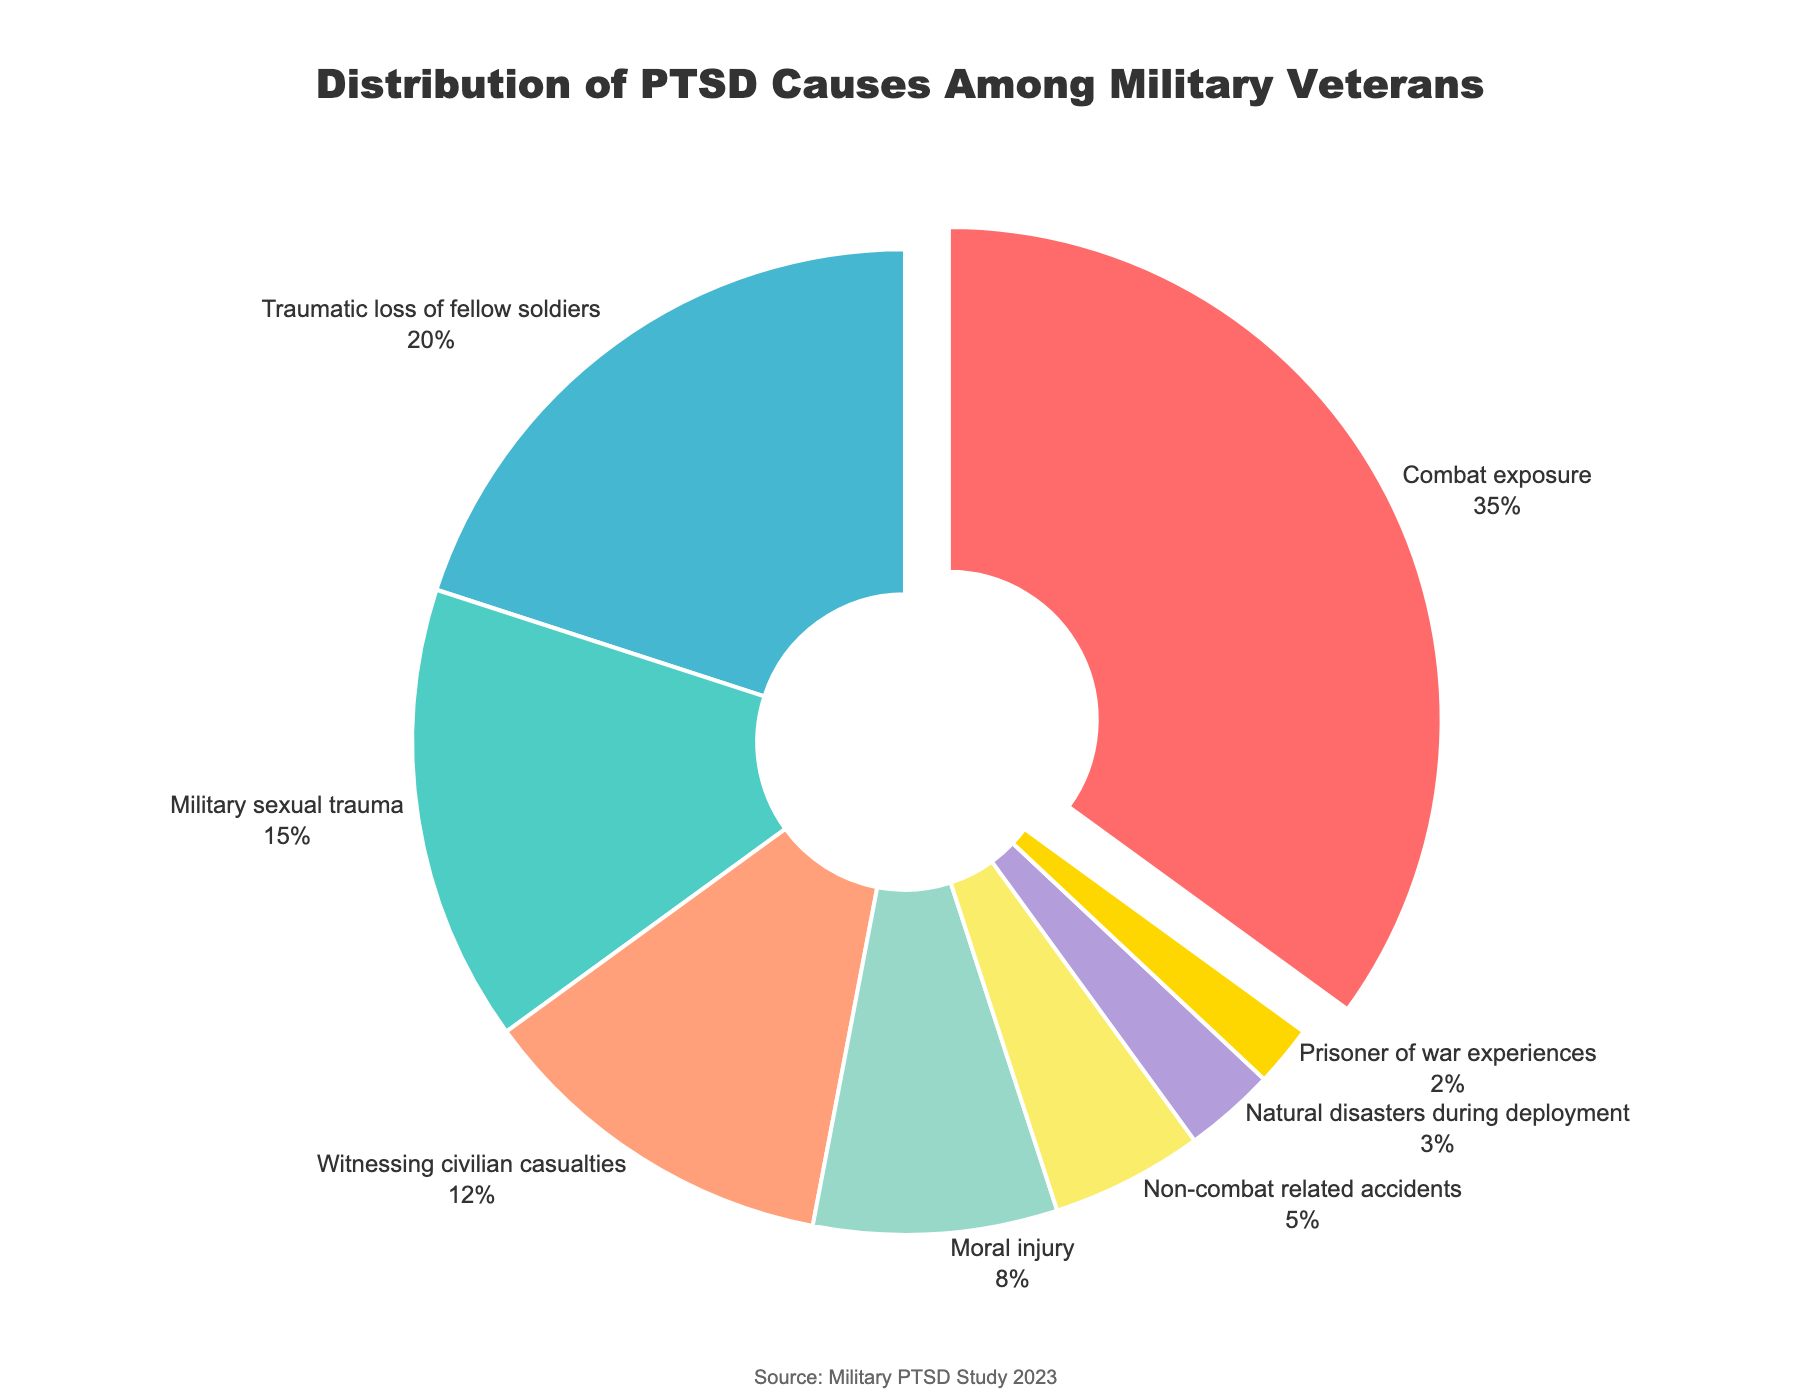What is the largest cause of PTSD among military veterans? The figure shows that "Combat exposure" is the largest slice of the pie, indicating it has the highest percentage.
Answer: Combat exposure What is the combined percentage of "Military sexual trauma" and "Traumatic loss of fellow soldiers"? "Military sexual trauma" is 15% and "Traumatic loss of fellow soldiers" is 20%. Adding these gives 15 + 20 = 35%.
Answer: 35% Which cause has a higher percentage: "Witnessing civilian casualties" or "Moral injury"? "Witnessing civilian casualties" is 12% and "Moral injury" is 8%. 12% is greater than 8%.
Answer: Witnessing civilian casualties What percentage of PTSD cases are caused by "Non-combat related accidents" and "Natural disasters during deployment" combined? "Non-combat related accidents" is 5% and "Natural disasters during deployment" is 3%. Adding these gives 5 + 3 = 8%.
Answer: 8% Which cause has the smallest percentage of PTSD among military veterans? The smallest slice of the pie is "Prisoner of war experiences" which is 2%.
Answer: Prisoner of war experiences How much more prevalent is "Traumatic loss of fellow soldiers" compared to "Non-combat related accidents"? "Traumatic loss of fellow soldiers" is 20% and "Non-combat related accidents" is 5%. The difference is 20 - 5 = 15%.
Answer: 15% What is the percentage of PTSD causes attributed to "Military sexual trauma" relative to "Combat exposure"? "Combat exposure" is 35% and "Military sexual trauma" is 15%. The relative percentage is (15 / 35) * 100 ≈ 42.86%.
Answer: ~42.86% Which causes have percentages above 10%? The pie chart shows that "Combat exposure" (35%), "Traumatic loss of fellow soldiers" (20%), and "Witnessing civilian casualties" (12%) all have percentages above 10%.
Answer: Combat exposure, Traumatic loss of fellow soldiers, Witnessing civilian casualties What is the difference in percentage between "Combat exposure" and "Moral injury"? "Combat exposure" is 35% and "Moral injury" is 8%. The difference is 35 - 8 = 27%.
Answer: 27% What percentage of causes is less than 5%? The categories under 5% are "Natural disasters during deployment" (3%) and "Prisoner of war experiences" (2%). Adding these gives 3 + 2 = 5%.
Answer: 5% 